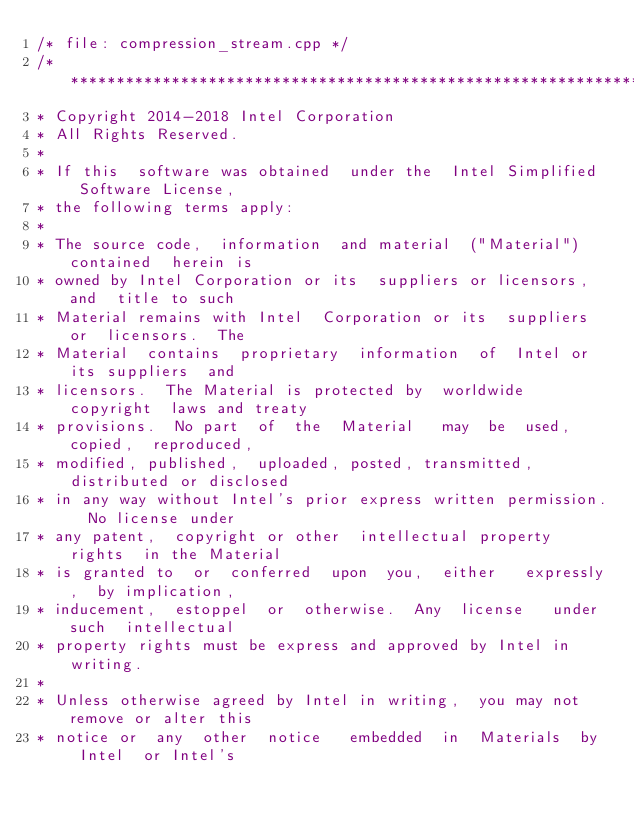Convert code to text. <code><loc_0><loc_0><loc_500><loc_500><_C++_>/* file: compression_stream.cpp */
/*******************************************************************************
* Copyright 2014-2018 Intel Corporation
* All Rights Reserved.
*
* If this  software was obtained  under the  Intel Simplified  Software License,
* the following terms apply:
*
* The source code,  information  and material  ("Material") contained  herein is
* owned by Intel Corporation or its  suppliers or licensors,  and  title to such
* Material remains with Intel  Corporation or its  suppliers or  licensors.  The
* Material  contains  proprietary  information  of  Intel or  its suppliers  and
* licensors.  The Material is protected by  worldwide copyright  laws and treaty
* provisions.  No part  of  the  Material   may  be  used,  copied,  reproduced,
* modified, published,  uploaded, posted, transmitted,  distributed or disclosed
* in any way without Intel's prior express written permission.  No license under
* any patent,  copyright or other  intellectual property rights  in the Material
* is granted to  or  conferred  upon  you,  either   expressly,  by implication,
* inducement,  estoppel  or  otherwise.  Any  license   under such  intellectual
* property rights must be express and approved by Intel in writing.
*
* Unless otherwise agreed by Intel in writing,  you may not remove or alter this
* notice or  any  other  notice   embedded  in  Materials  by  Intel  or Intel's</code> 